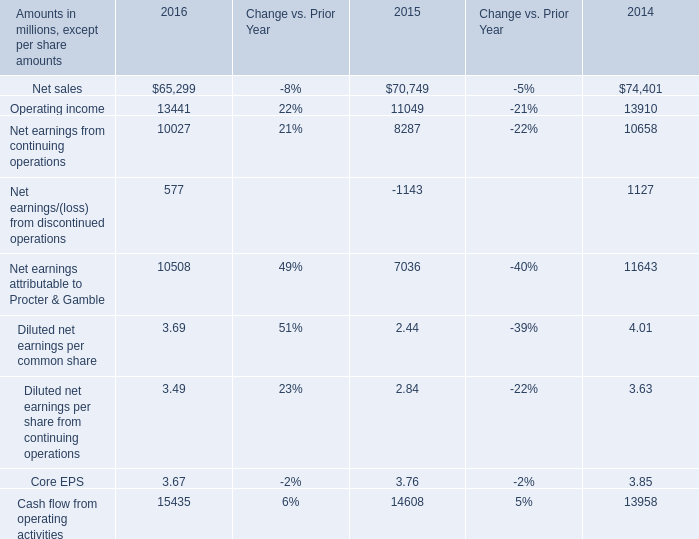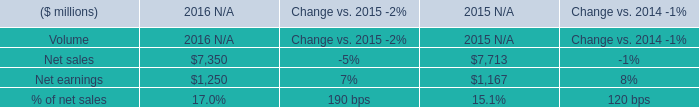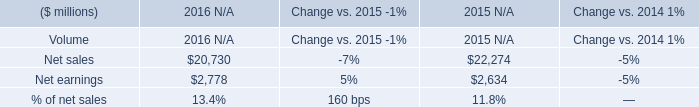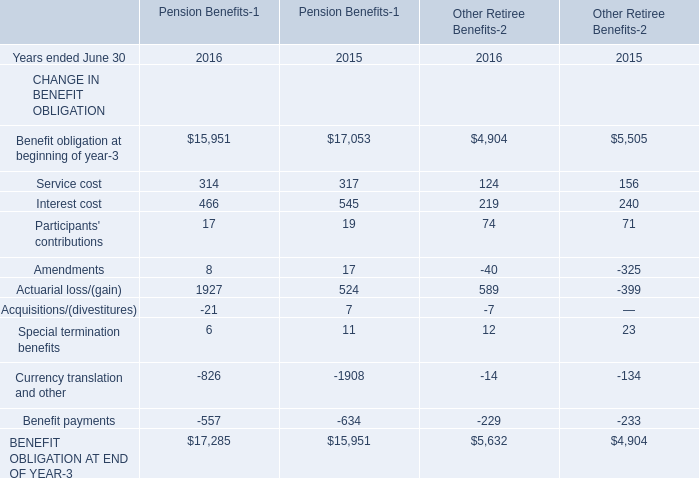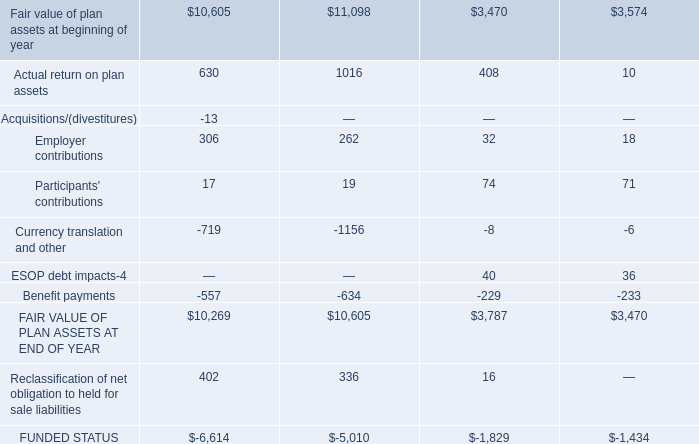What's the average of Fair value of plan assets at beginning of year, and Benefit obligation at beginning of year of Pension Benefits 2015 ? 
Computations: ((10605.0 + 17053.0) / 2)
Answer: 13829.0. 